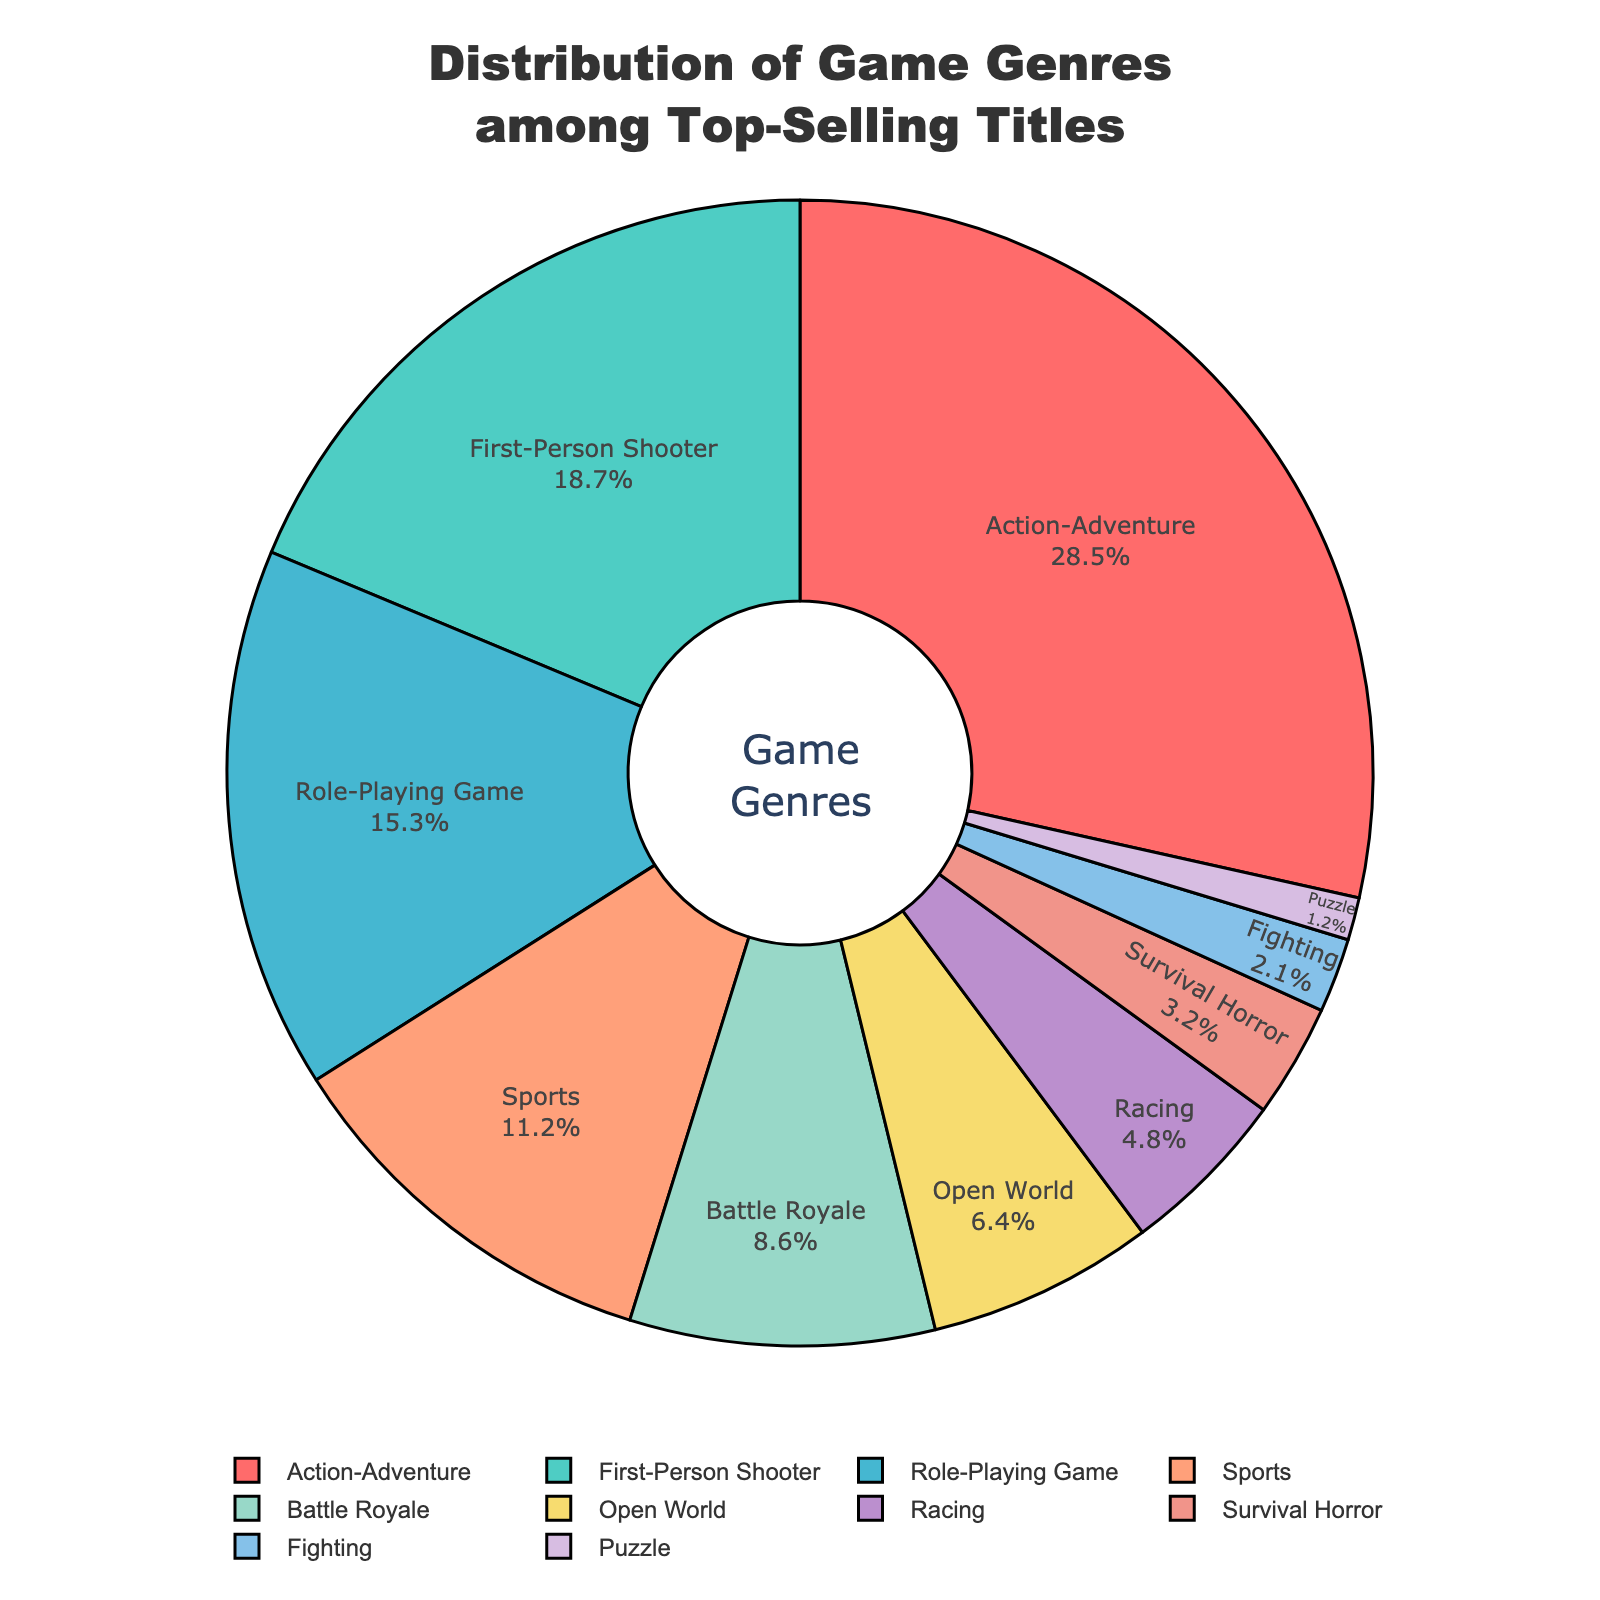What's the most popular game genre among top-selling titles? Look at the segment with the largest percentage. Action-Adventure occupies 28.5%, which is the highest.
Answer: Action-Adventure Which game genre has the smallest share in the pie chart? Identify the segment with the smallest percentage. Puzzle is the smallest with 1.2%.
Answer: Puzzle How much more popular is First-Person Shooter compared to Puzzle? Find the percentages of First-Person Shooter and Puzzle, then subtract the smaller from the larger (18.7 - 1.2).
Answer: 17.5 What is the combined percentage of Role-Playing Games and Sports games? Add the percentages of Role-Playing Game and Sports (15.3 + 11.2).
Answer: 26.5 Which genres combined have more than 60% of the top-selling titles? Add the segments' percentages until the sum exceeds 60%. Action-Adventure (28.5) + First-Person Shooter (18.7) + Role-Playing Game (15.3) = 62.5, so only these three genres.
Answer: Action-Adventure, First-Person Shooter, Role-Playing Game Is the Open World genre more popular than Racing? Compare the percentages of Open World and Racing. Open World has 6.4%, while Racing has 4.8%.
Answer: Yes How does the popularity of Survival Horror compare to Fighting? Compare the percentages of Survival Horror and Fighting. Survival Horror has 3.2%, and Fighting has 2.1%.
Answer: Survival Horror is more popular What percentage of the top-selling titles come from genres that have less than 10% share each? Add percentages for genres under 10%. Battle Royale (8.6) + Open World (6.4) + Racing (4.8) + Survival Horror (3.2) + Fighting (2.1) + Puzzle (1.2) = 26.3.
Answer: 26.3 Between Action-Adventure and Sports, which one is less popular and by how much? Find the percentages and subtract the smaller from the larger (28.5 - 11.2). Action-Adventure is more popular.
Answer: Sports by 17.3 Which genres occupy more than 5% but less than 20% of the pie chart? Identify the segments within the 5-20% range. First-Person Shooter (18.7), Role-Playing Game (15.3), Sports (11.2), Battle Royale (8.6), and Open World (6.4).
Answer: First-Person Shooter, Role-Playing Game, Sports, Battle Royale, Open World 